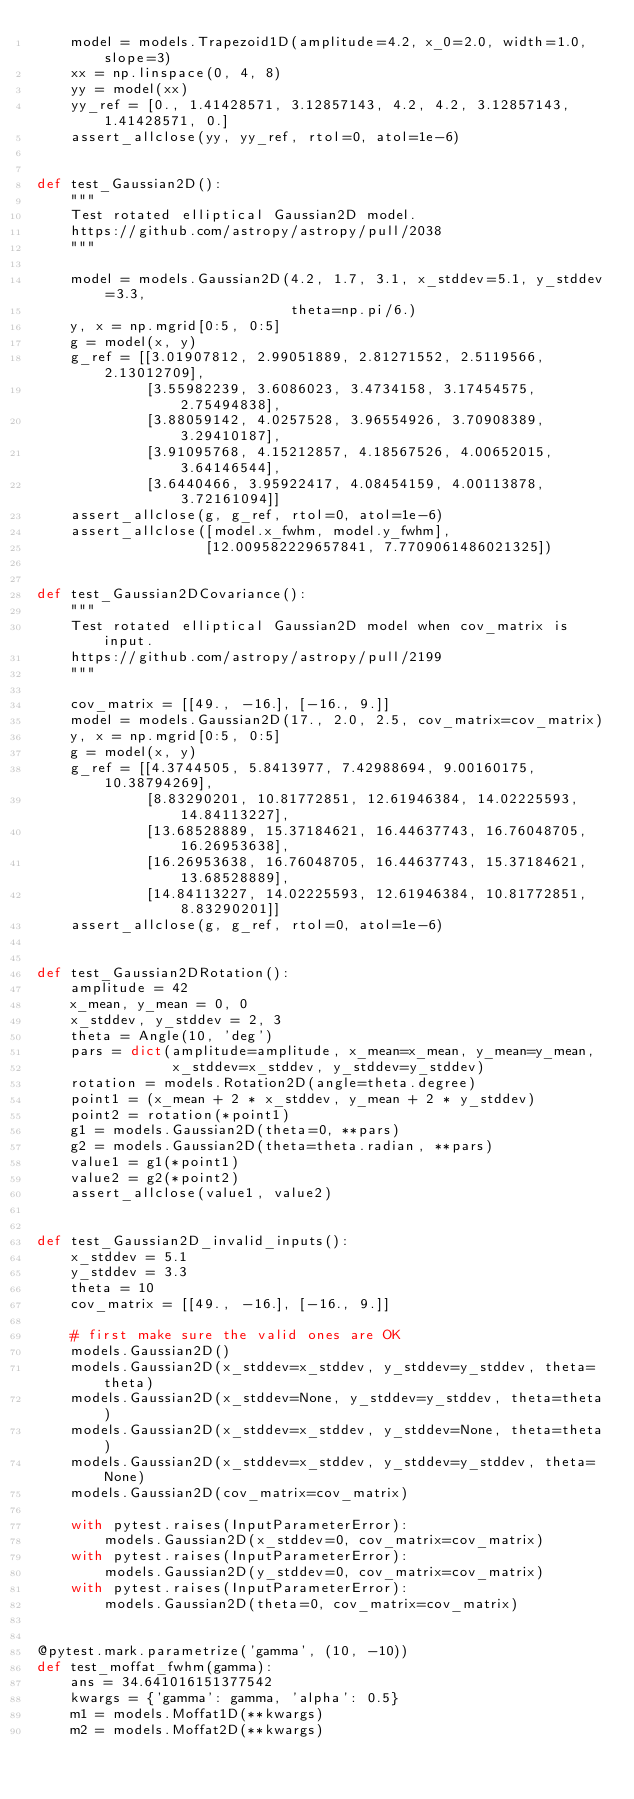Convert code to text. <code><loc_0><loc_0><loc_500><loc_500><_Python_>    model = models.Trapezoid1D(amplitude=4.2, x_0=2.0, width=1.0, slope=3)
    xx = np.linspace(0, 4, 8)
    yy = model(xx)
    yy_ref = [0., 1.41428571, 3.12857143, 4.2, 4.2, 3.12857143, 1.41428571, 0.]
    assert_allclose(yy, yy_ref, rtol=0, atol=1e-6)


def test_Gaussian2D():
    """
    Test rotated elliptical Gaussian2D model.
    https://github.com/astropy/astropy/pull/2038
    """

    model = models.Gaussian2D(4.2, 1.7, 3.1, x_stddev=5.1, y_stddev=3.3,
                              theta=np.pi/6.)
    y, x = np.mgrid[0:5, 0:5]
    g = model(x, y)
    g_ref = [[3.01907812, 2.99051889, 2.81271552, 2.5119566, 2.13012709],
             [3.55982239, 3.6086023, 3.4734158, 3.17454575, 2.75494838],
             [3.88059142, 4.0257528, 3.96554926, 3.70908389, 3.29410187],
             [3.91095768, 4.15212857, 4.18567526, 4.00652015, 3.64146544],
             [3.6440466, 3.95922417, 4.08454159, 4.00113878, 3.72161094]]
    assert_allclose(g, g_ref, rtol=0, atol=1e-6)
    assert_allclose([model.x_fwhm, model.y_fwhm],
                    [12.009582229657841, 7.7709061486021325])


def test_Gaussian2DCovariance():
    """
    Test rotated elliptical Gaussian2D model when cov_matrix is input.
    https://github.com/astropy/astropy/pull/2199
    """

    cov_matrix = [[49., -16.], [-16., 9.]]
    model = models.Gaussian2D(17., 2.0, 2.5, cov_matrix=cov_matrix)
    y, x = np.mgrid[0:5, 0:5]
    g = model(x, y)
    g_ref = [[4.3744505, 5.8413977, 7.42988694, 9.00160175, 10.38794269],
             [8.83290201, 10.81772851, 12.61946384, 14.02225593, 14.84113227],
             [13.68528889, 15.37184621, 16.44637743, 16.76048705, 16.26953638],
             [16.26953638, 16.76048705, 16.44637743, 15.37184621, 13.68528889],
             [14.84113227, 14.02225593, 12.61946384, 10.81772851, 8.83290201]]
    assert_allclose(g, g_ref, rtol=0, atol=1e-6)


def test_Gaussian2DRotation():
    amplitude = 42
    x_mean, y_mean = 0, 0
    x_stddev, y_stddev = 2, 3
    theta = Angle(10, 'deg')
    pars = dict(amplitude=amplitude, x_mean=x_mean, y_mean=y_mean,
                x_stddev=x_stddev, y_stddev=y_stddev)
    rotation = models.Rotation2D(angle=theta.degree)
    point1 = (x_mean + 2 * x_stddev, y_mean + 2 * y_stddev)
    point2 = rotation(*point1)
    g1 = models.Gaussian2D(theta=0, **pars)
    g2 = models.Gaussian2D(theta=theta.radian, **pars)
    value1 = g1(*point1)
    value2 = g2(*point2)
    assert_allclose(value1, value2)


def test_Gaussian2D_invalid_inputs():
    x_stddev = 5.1
    y_stddev = 3.3
    theta = 10
    cov_matrix = [[49., -16.], [-16., 9.]]

    # first make sure the valid ones are OK
    models.Gaussian2D()
    models.Gaussian2D(x_stddev=x_stddev, y_stddev=y_stddev, theta=theta)
    models.Gaussian2D(x_stddev=None, y_stddev=y_stddev, theta=theta)
    models.Gaussian2D(x_stddev=x_stddev, y_stddev=None, theta=theta)
    models.Gaussian2D(x_stddev=x_stddev, y_stddev=y_stddev, theta=None)
    models.Gaussian2D(cov_matrix=cov_matrix)

    with pytest.raises(InputParameterError):
        models.Gaussian2D(x_stddev=0, cov_matrix=cov_matrix)
    with pytest.raises(InputParameterError):
        models.Gaussian2D(y_stddev=0, cov_matrix=cov_matrix)
    with pytest.raises(InputParameterError):
        models.Gaussian2D(theta=0, cov_matrix=cov_matrix)


@pytest.mark.parametrize('gamma', (10, -10))
def test_moffat_fwhm(gamma):
    ans = 34.641016151377542
    kwargs = {'gamma': gamma, 'alpha': 0.5}
    m1 = models.Moffat1D(**kwargs)
    m2 = models.Moffat2D(**kwargs)</code> 